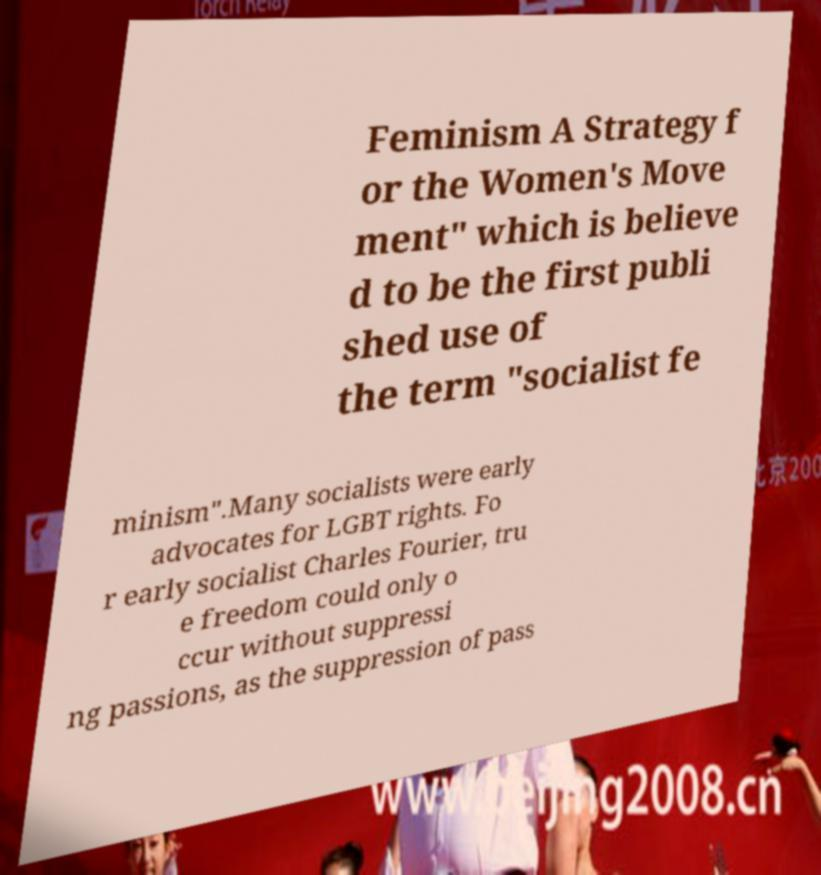Can you read and provide the text displayed in the image?This photo seems to have some interesting text. Can you extract and type it out for me? Feminism A Strategy f or the Women's Move ment" which is believe d to be the first publi shed use of the term "socialist fe minism".Many socialists were early advocates for LGBT rights. Fo r early socialist Charles Fourier, tru e freedom could only o ccur without suppressi ng passions, as the suppression of pass 